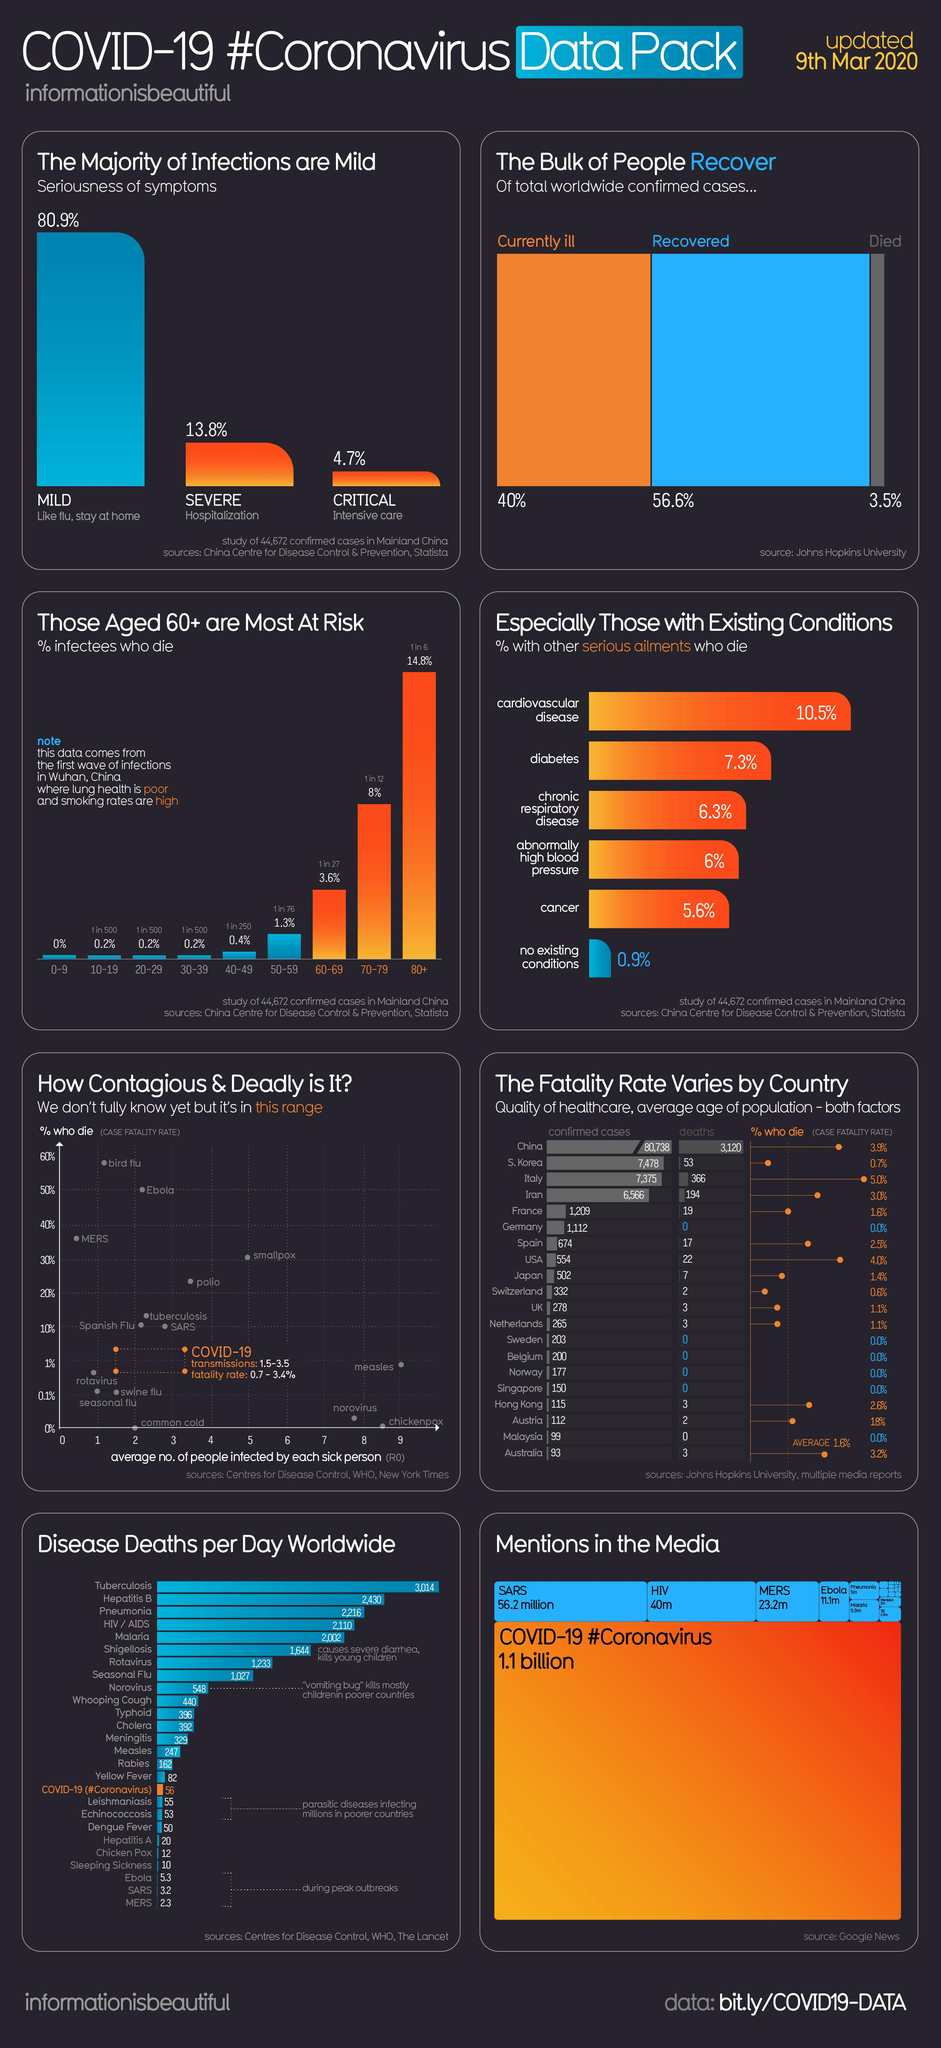Outline some significant characteristics in this image. According to recent reports, approximately 16.1% of people who have died from the COVID-19 virus have succumbed to cardiovascular disease and cancer. 